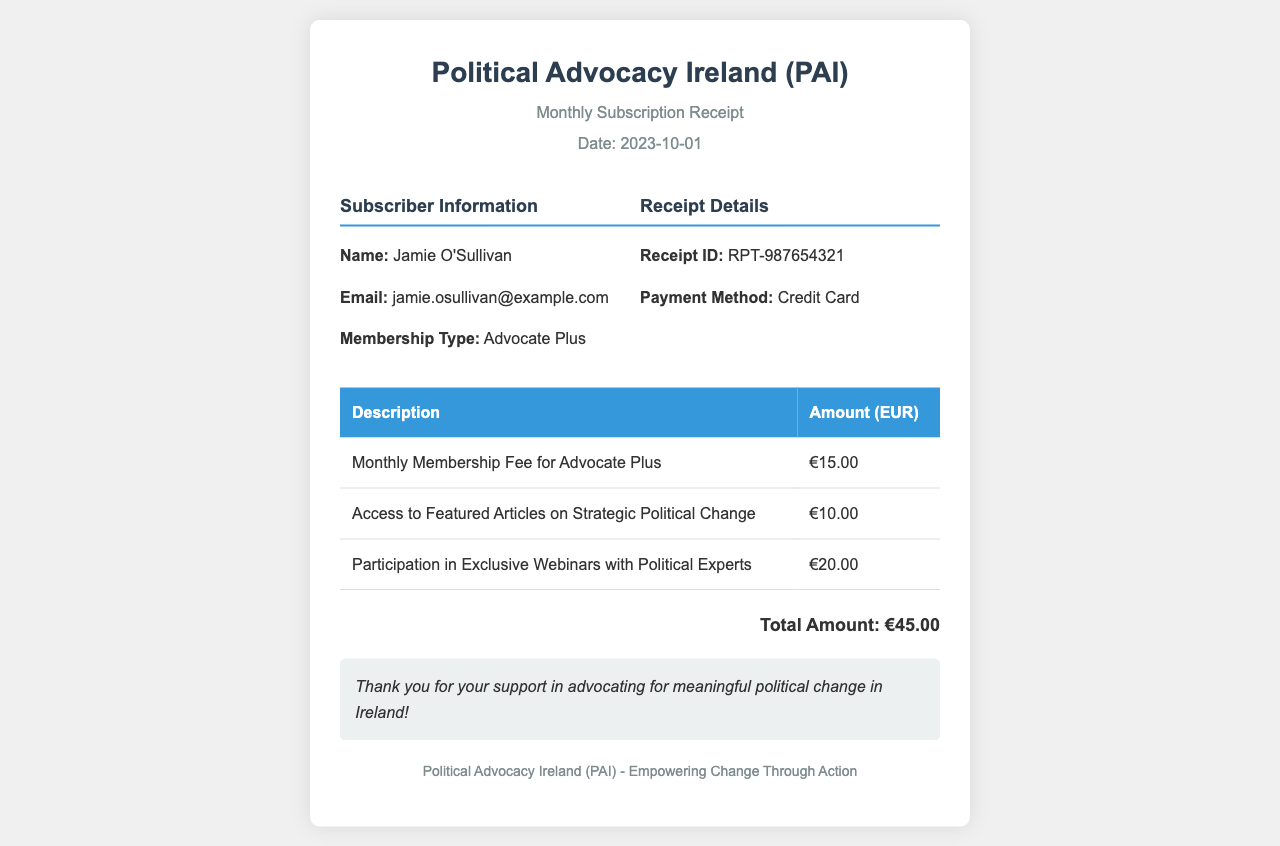what is the name of the subscriber? The name of the subscriber is mentioned in the subscriber information section.
Answer: Jamie O'Sullivan what is the total amount charged? The total amount is presented at the bottom of the receipt after all charges are listed.
Answer: €45.00 when was the payment made? The date of the receipt is clearly stated in the header section of the document.
Answer: 2023-10-01 what is the receipt ID? The receipt ID is found in the receipt details section, providing a unique identifier for this transaction.
Answer: RPT-987654321 how much does the membership fee cost? The membership fee is specified in the table detailing charges, under its description.
Answer: €15.00 how many exclusive webinars are included in the subscription? The document specifies participation in exclusive webinars, indicating one subscription type that includes it.
Answer: Participation in Exclusive Webinars what is the payment method used? The payment method is indicated in the receipt details section of the document.
Answer: Credit Card what type of membership does the subscriber have? The membership type is noted in the subscriber information section.
Answer: Advocate Plus how much is the charge for featured articles? The amount for featured articles is listed in the table of charges.
Answer: €10.00 